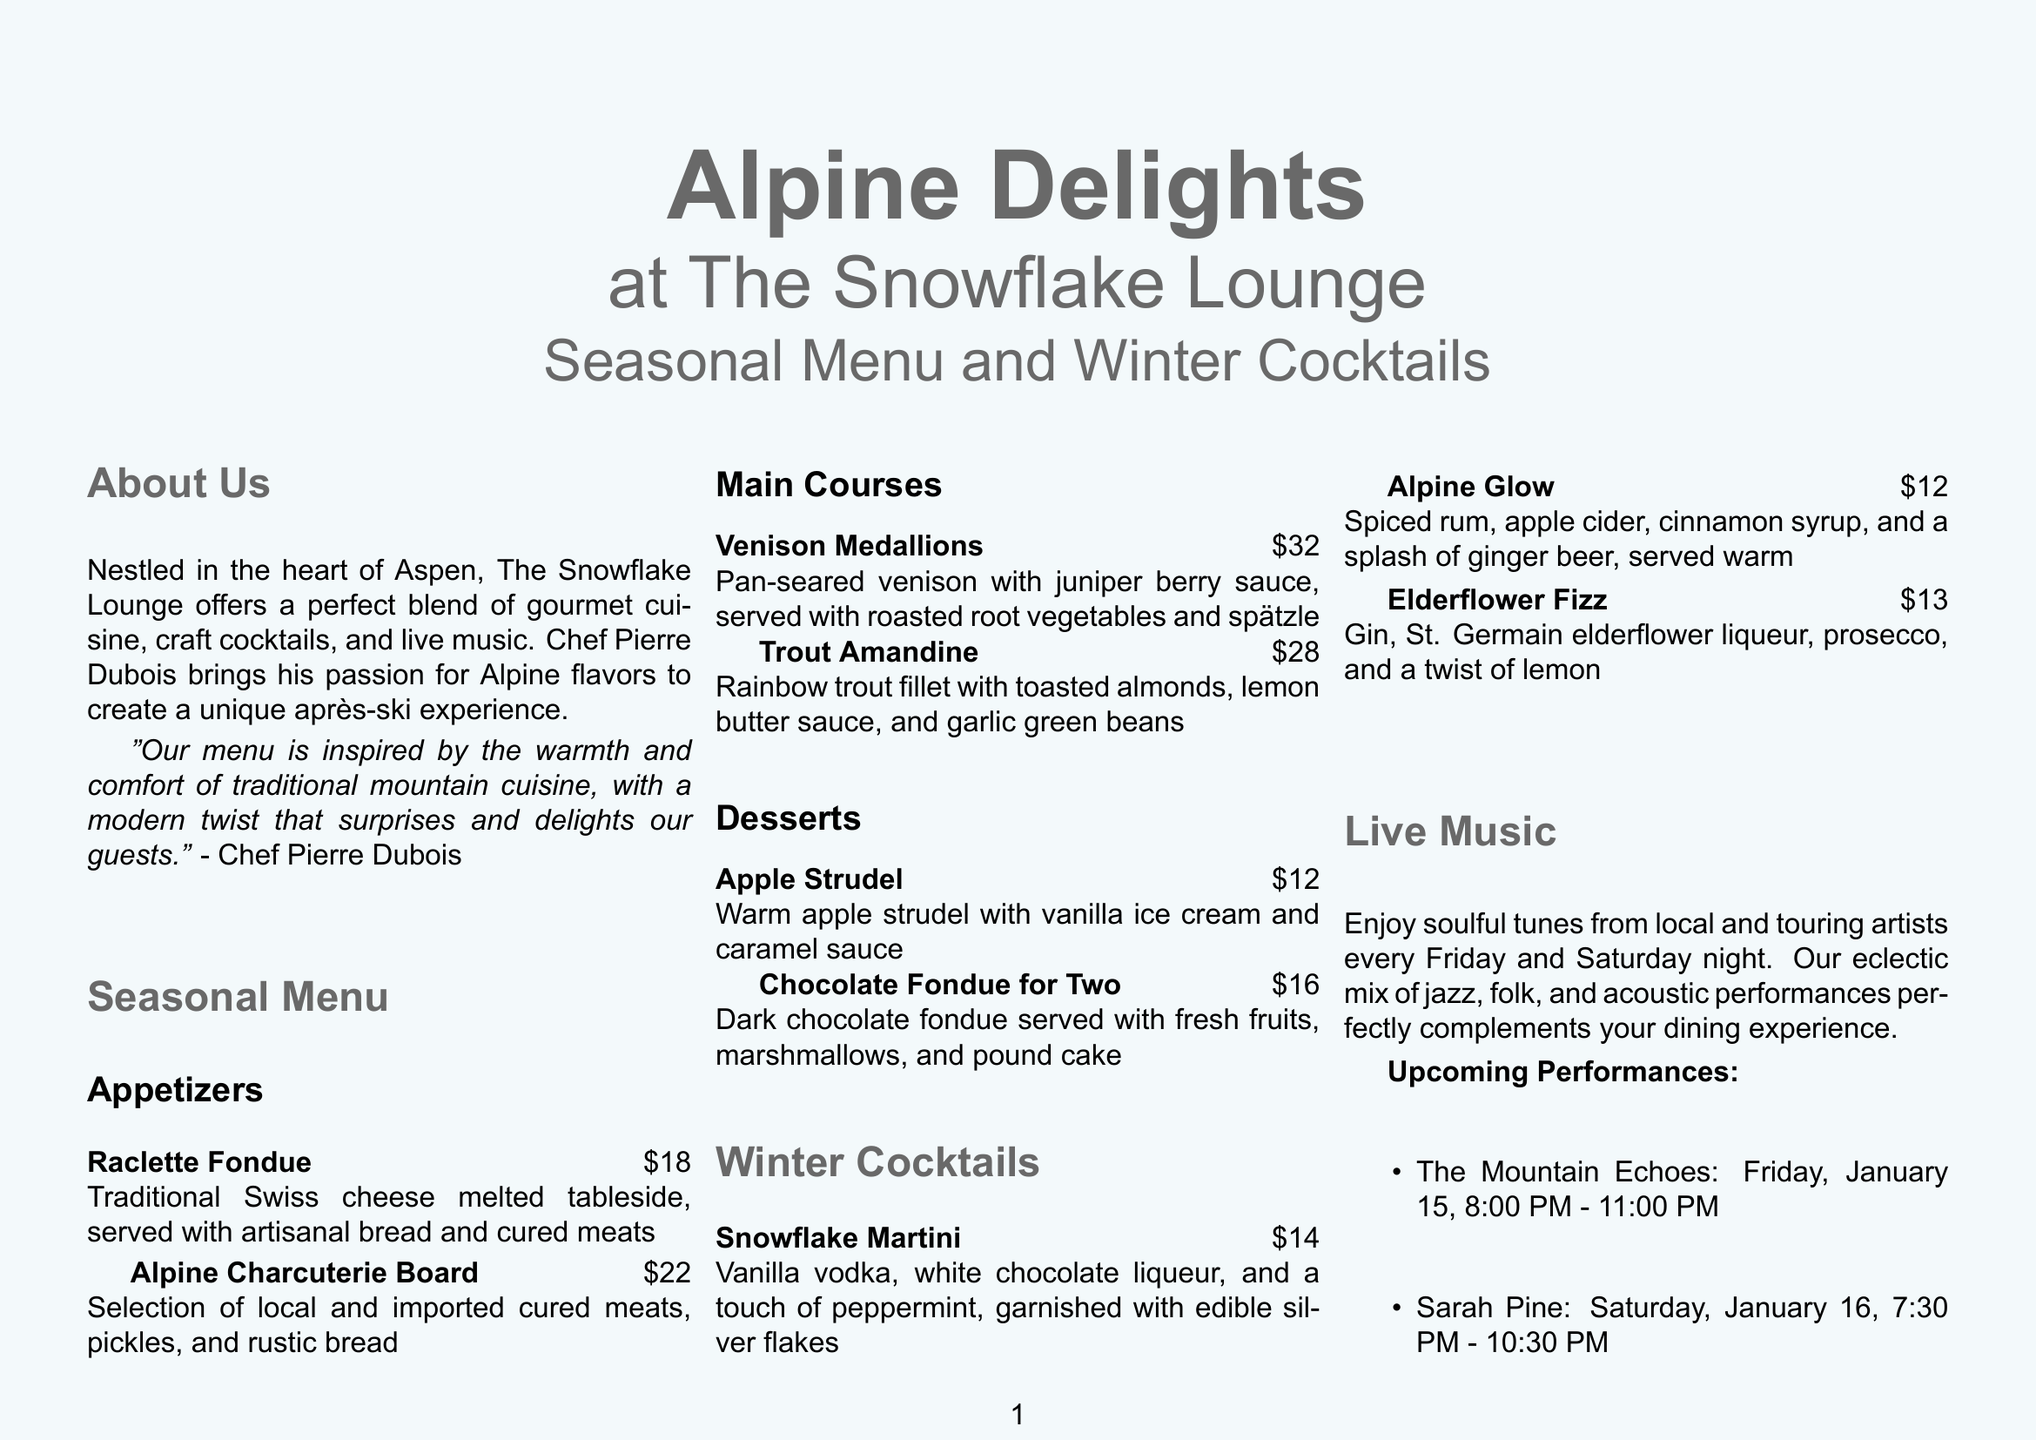What is the title of the brochure? The title of the brochure is prominently displayed at the top of the cover section.
Answer: Alpine Delights at The Snowflake Lounge Who is the chef at The Snowflake Lounge? The chef is introduced in the "About Us" section along with a quote about the menu.
Answer: Chef Pierre Dubois What is the price of the Raclette Fondue? The "Seasonal Menu" section lists the price next to the dish name.
Answer: $18 What are the main courses offered? The document lists the main courses under the "Seasonal Menu" section.
Answer: Venison Medallions, Trout Amandine When does live music take place at the lounge? The "Live Music" section specifies the days for performances.
Answer: Friday and Saturday What is the address of The Snowflake Lounge? The address is provided in the "Contact and Location" section of the brochure.
Answer: 123 Powder Lane, Aspen, CO 81611 What is the signature drink with edible silver flakes? The "Winter Cocktails" section details specific drinks and ingredients.
Answer: Snowflake Martini How many desserts are listed in the menu? The "Seasonal Menu" section provides a count of desserts.
Answer: Two 